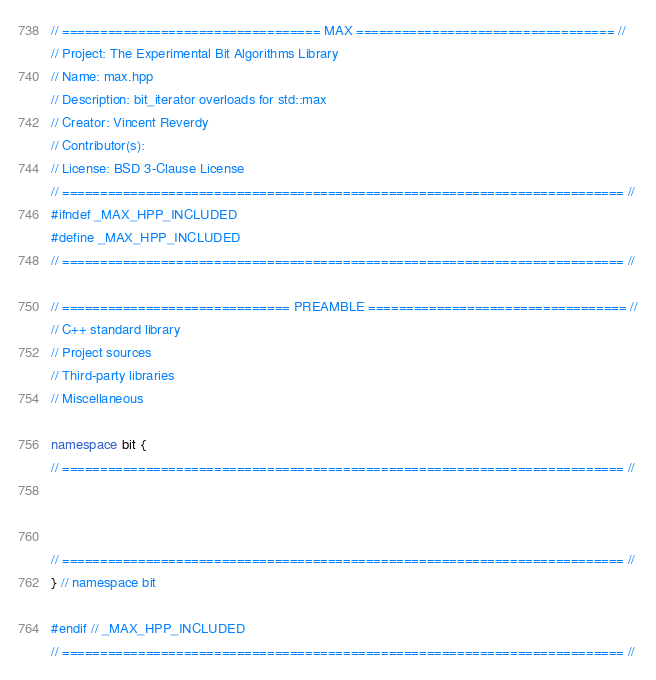<code> <loc_0><loc_0><loc_500><loc_500><_C++_>// ================================== MAX ================================== //
// Project: The Experimental Bit Algorithms Library
// Name: max.hpp
// Description: bit_iterator overloads for std::max
// Creator: Vincent Reverdy
// Contributor(s): 
// License: BSD 3-Clause License
// ========================================================================== //
#ifndef _MAX_HPP_INCLUDED
#define _MAX_HPP_INCLUDED
// ========================================================================== //

// ============================== PREAMBLE ================================== //
// C++ standard library
// Project sources
// Third-party libraries
// Miscellaneous

namespace bit {
// ========================================================================== //



// ========================================================================== //
} // namespace bit

#endif // _MAX_HPP_INCLUDED
// ========================================================================== //
</code> 